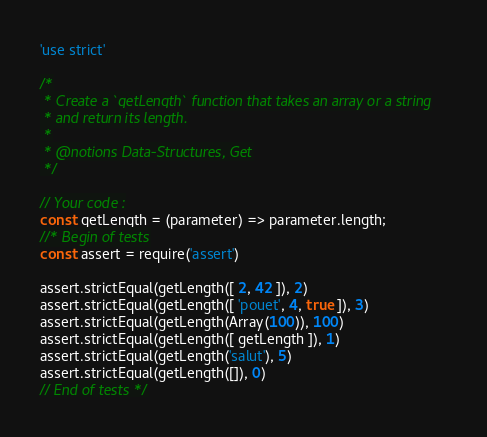<code> <loc_0><loc_0><loc_500><loc_500><_JavaScript_>'use strict'

/*
 * Create a `getLength` function that takes an array or a string
 * and return its length.
 *
 * @notions Data-Structures, Get
 */

// Your code :
const getLength = (parameter) => parameter.length;
//* Begin of tests
const assert = require('assert')

assert.strictEqual(getLength([ 2, 42 ]), 2)
assert.strictEqual(getLength([ 'pouet', 4, true ]), 3)
assert.strictEqual(getLength(Array(100)), 100)
assert.strictEqual(getLength([ getLength ]), 1)
assert.strictEqual(getLength('salut'), 5)
assert.strictEqual(getLength([]), 0)
// End of tests */
</code> 